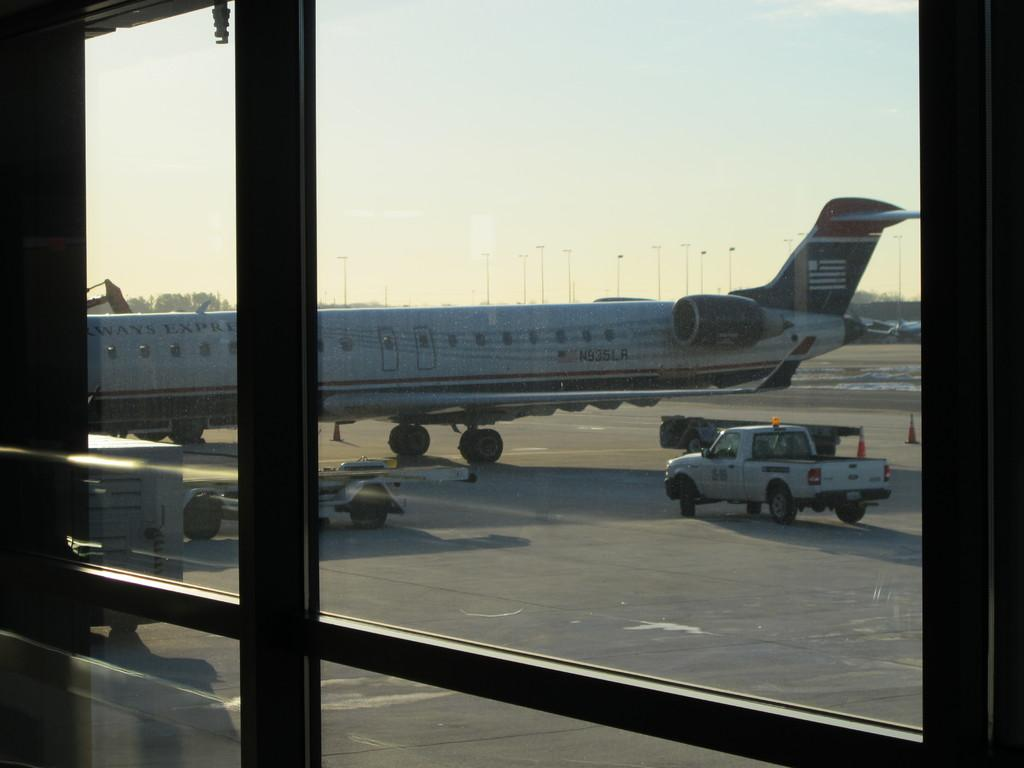What type of door is present in the image? There is a glass door in the image. What can be seen through the glass door? A vehicle is visible behind the glass door. What mode of transportation is on the land in the image? There is an airplane on the land in the image. What part of the natural environment is visible in the image? The sky is visible in the image. What type of waste is being collected on the street in the image? There is no street or waste collection present in the image. What book is the person reading in the image? There is no person or book visible in the image. 